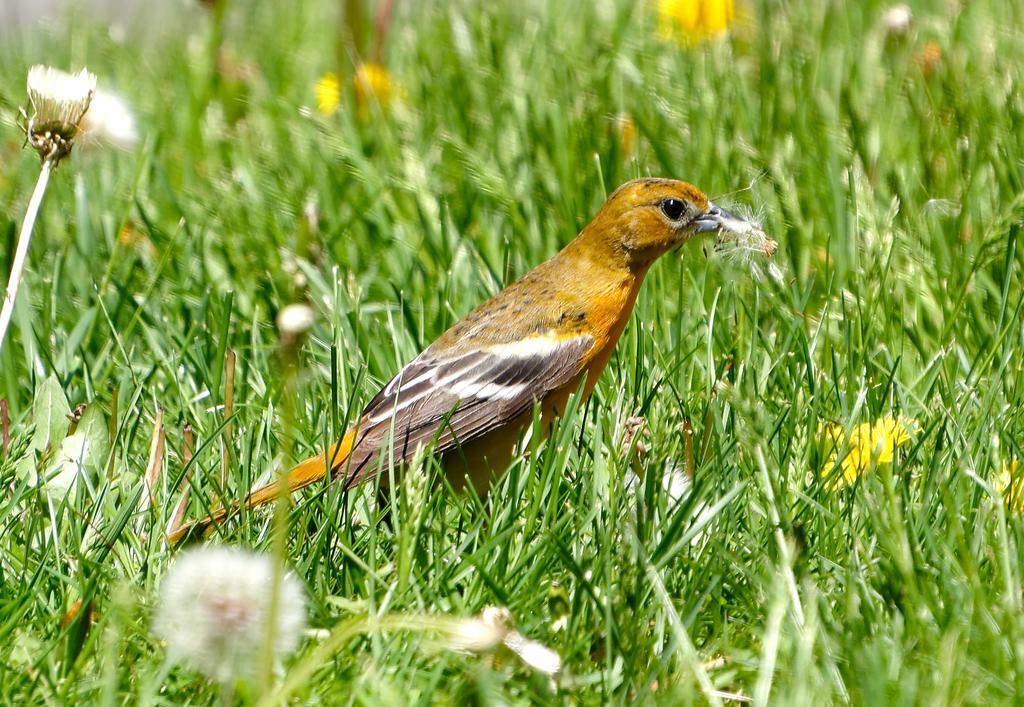In one or two sentences, can you explain what this image depicts? In this image there is a bird on the grass and we can see the flowers at the bottom of the image. 